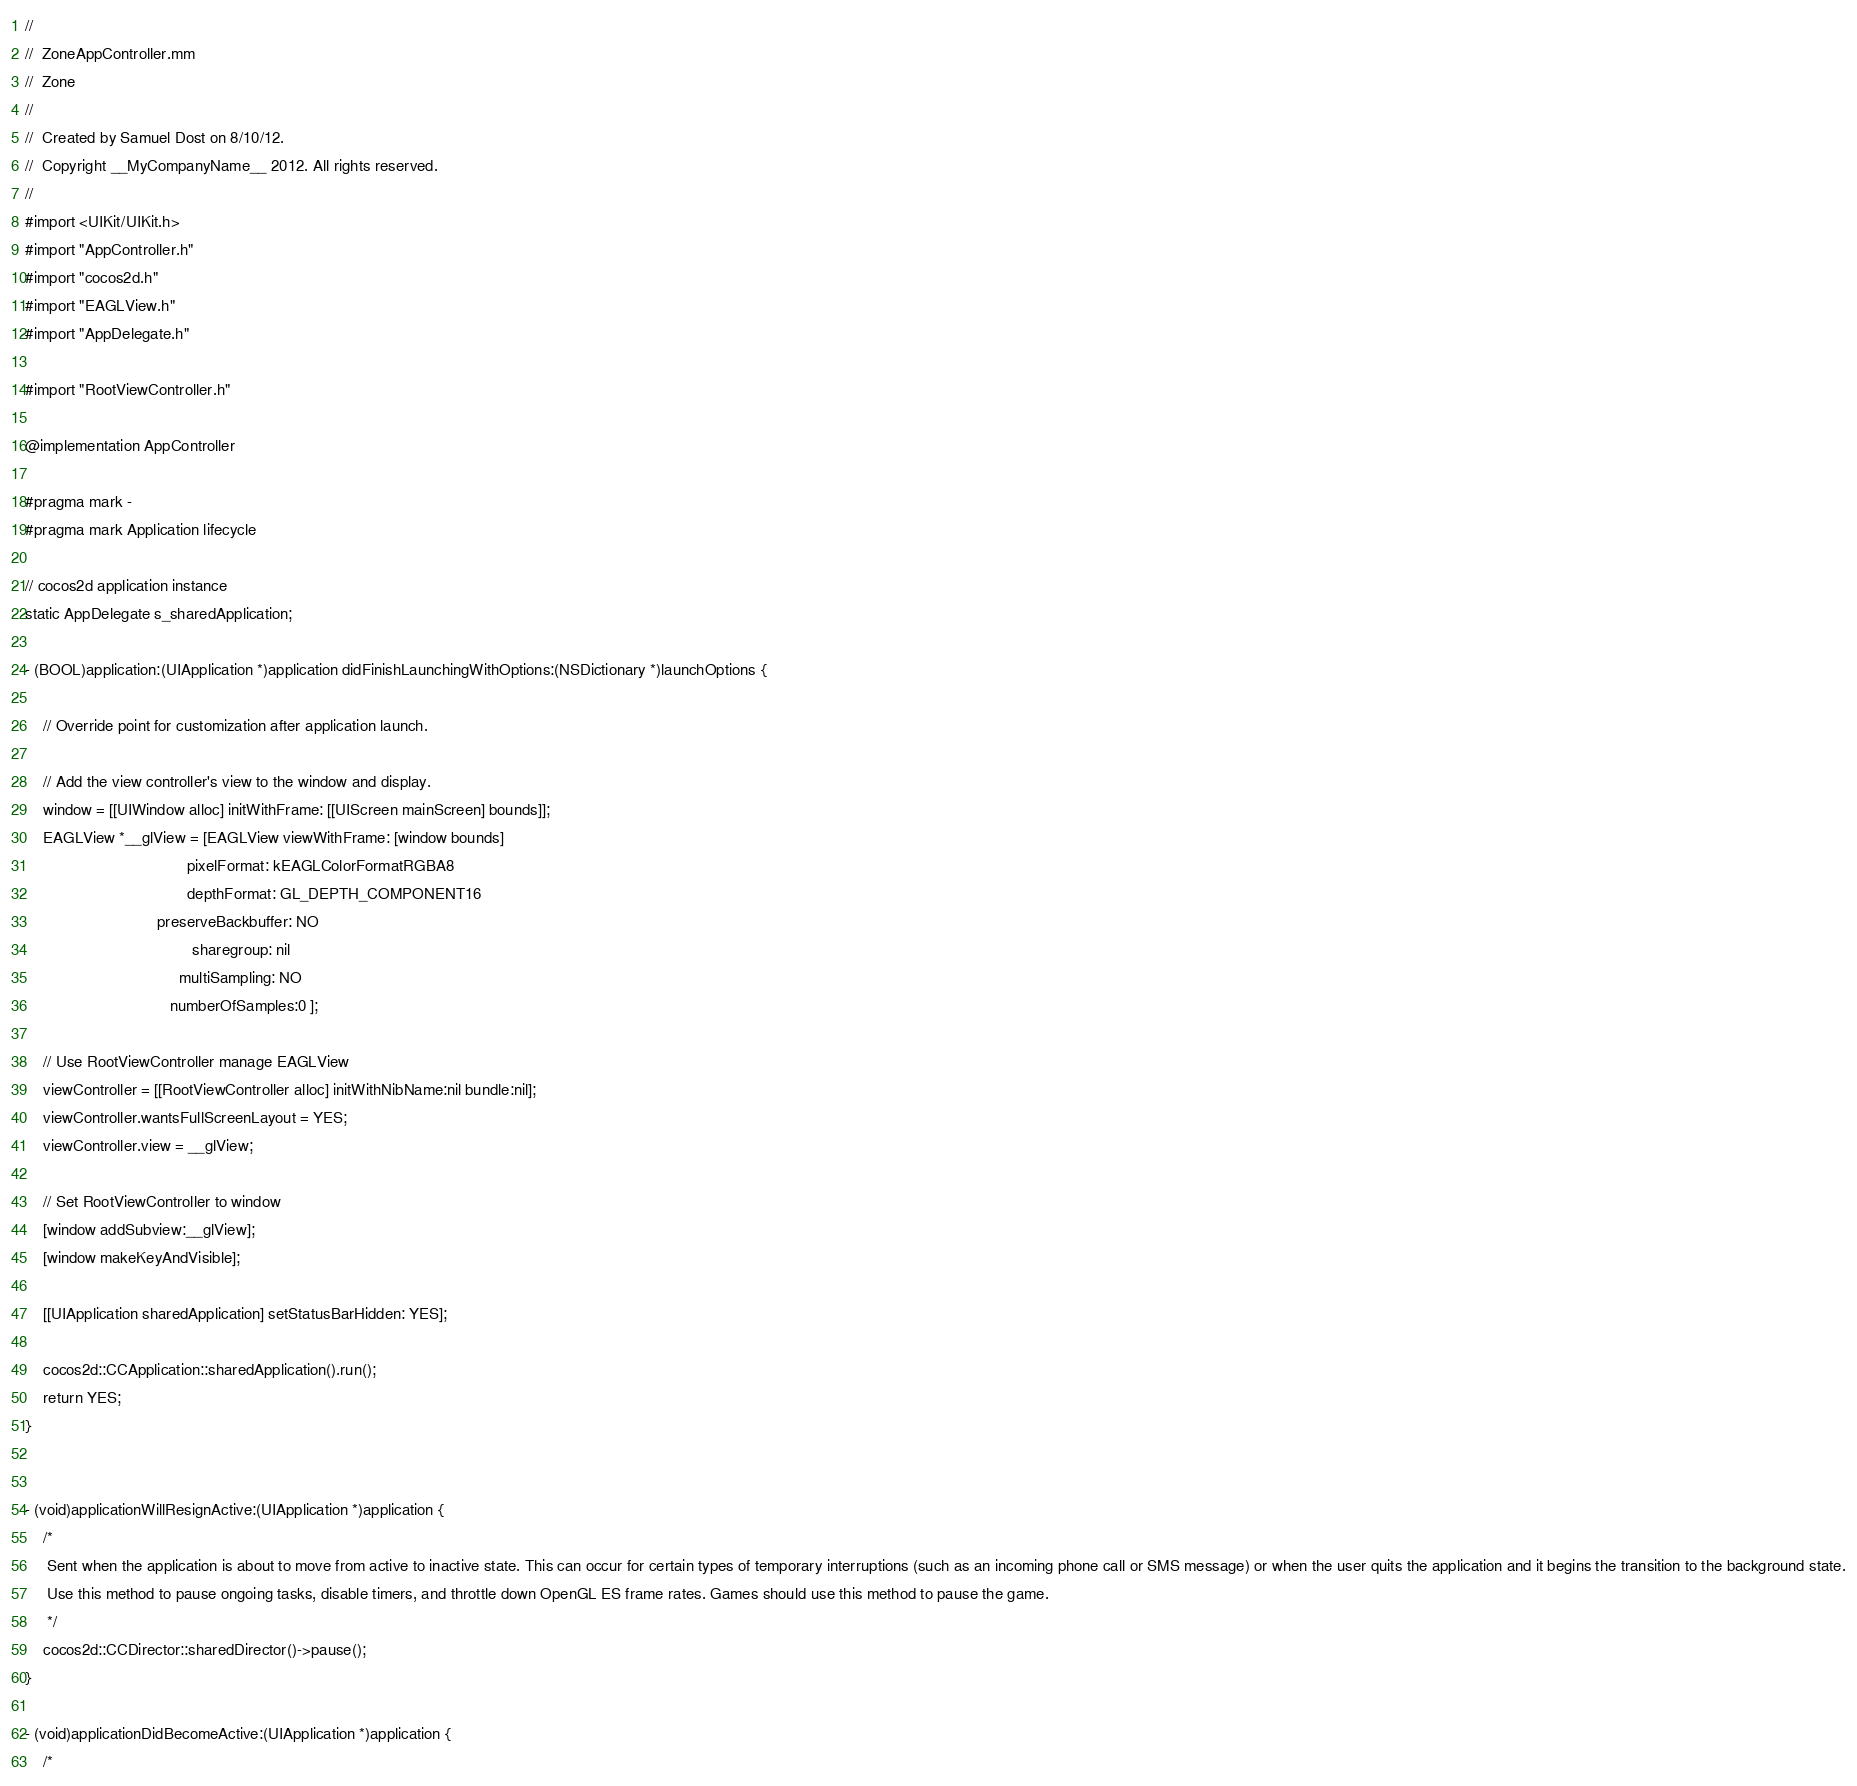Convert code to text. <code><loc_0><loc_0><loc_500><loc_500><_ObjectiveC_>//
//  ZoneAppController.mm
//  Zone
//
//  Created by Samuel Dost on 8/10/12.
//  Copyright __MyCompanyName__ 2012. All rights reserved.
//
#import <UIKit/UIKit.h>
#import "AppController.h"
#import "cocos2d.h"
#import "EAGLView.h"
#import "AppDelegate.h"

#import "RootViewController.h"

@implementation AppController

#pragma mark -
#pragma mark Application lifecycle

// cocos2d application instance
static AppDelegate s_sharedApplication;

- (BOOL)application:(UIApplication *)application didFinishLaunchingWithOptions:(NSDictionary *)launchOptions {

    // Override point for customization after application launch.

    // Add the view controller's view to the window and display.
    window = [[UIWindow alloc] initWithFrame: [[UIScreen mainScreen] bounds]];
    EAGLView *__glView = [EAGLView viewWithFrame: [window bounds]
                                     pixelFormat: kEAGLColorFormatRGBA8
                                     depthFormat: GL_DEPTH_COMPONENT16
                              preserveBackbuffer: NO
                                      sharegroup: nil
                                   multiSampling: NO
                                 numberOfSamples:0 ];

    // Use RootViewController manage EAGLView
    viewController = [[RootViewController alloc] initWithNibName:nil bundle:nil];
    viewController.wantsFullScreenLayout = YES;
    viewController.view = __glView;

    // Set RootViewController to window
    [window addSubview:__glView];
    [window makeKeyAndVisible];

    [[UIApplication sharedApplication] setStatusBarHidden: YES];

    cocos2d::CCApplication::sharedApplication().run();
    return YES;
}


- (void)applicationWillResignActive:(UIApplication *)application {
    /*
     Sent when the application is about to move from active to inactive state. This can occur for certain types of temporary interruptions (such as an incoming phone call or SMS message) or when the user quits the application and it begins the transition to the background state.
     Use this method to pause ongoing tasks, disable timers, and throttle down OpenGL ES frame rates. Games should use this method to pause the game.
     */
    cocos2d::CCDirector::sharedDirector()->pause();
}

- (void)applicationDidBecomeActive:(UIApplication *)application {
    /*</code> 